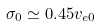<formula> <loc_0><loc_0><loc_500><loc_500>\sigma _ { 0 } \simeq 0 . 4 5 v _ { e 0 }</formula> 